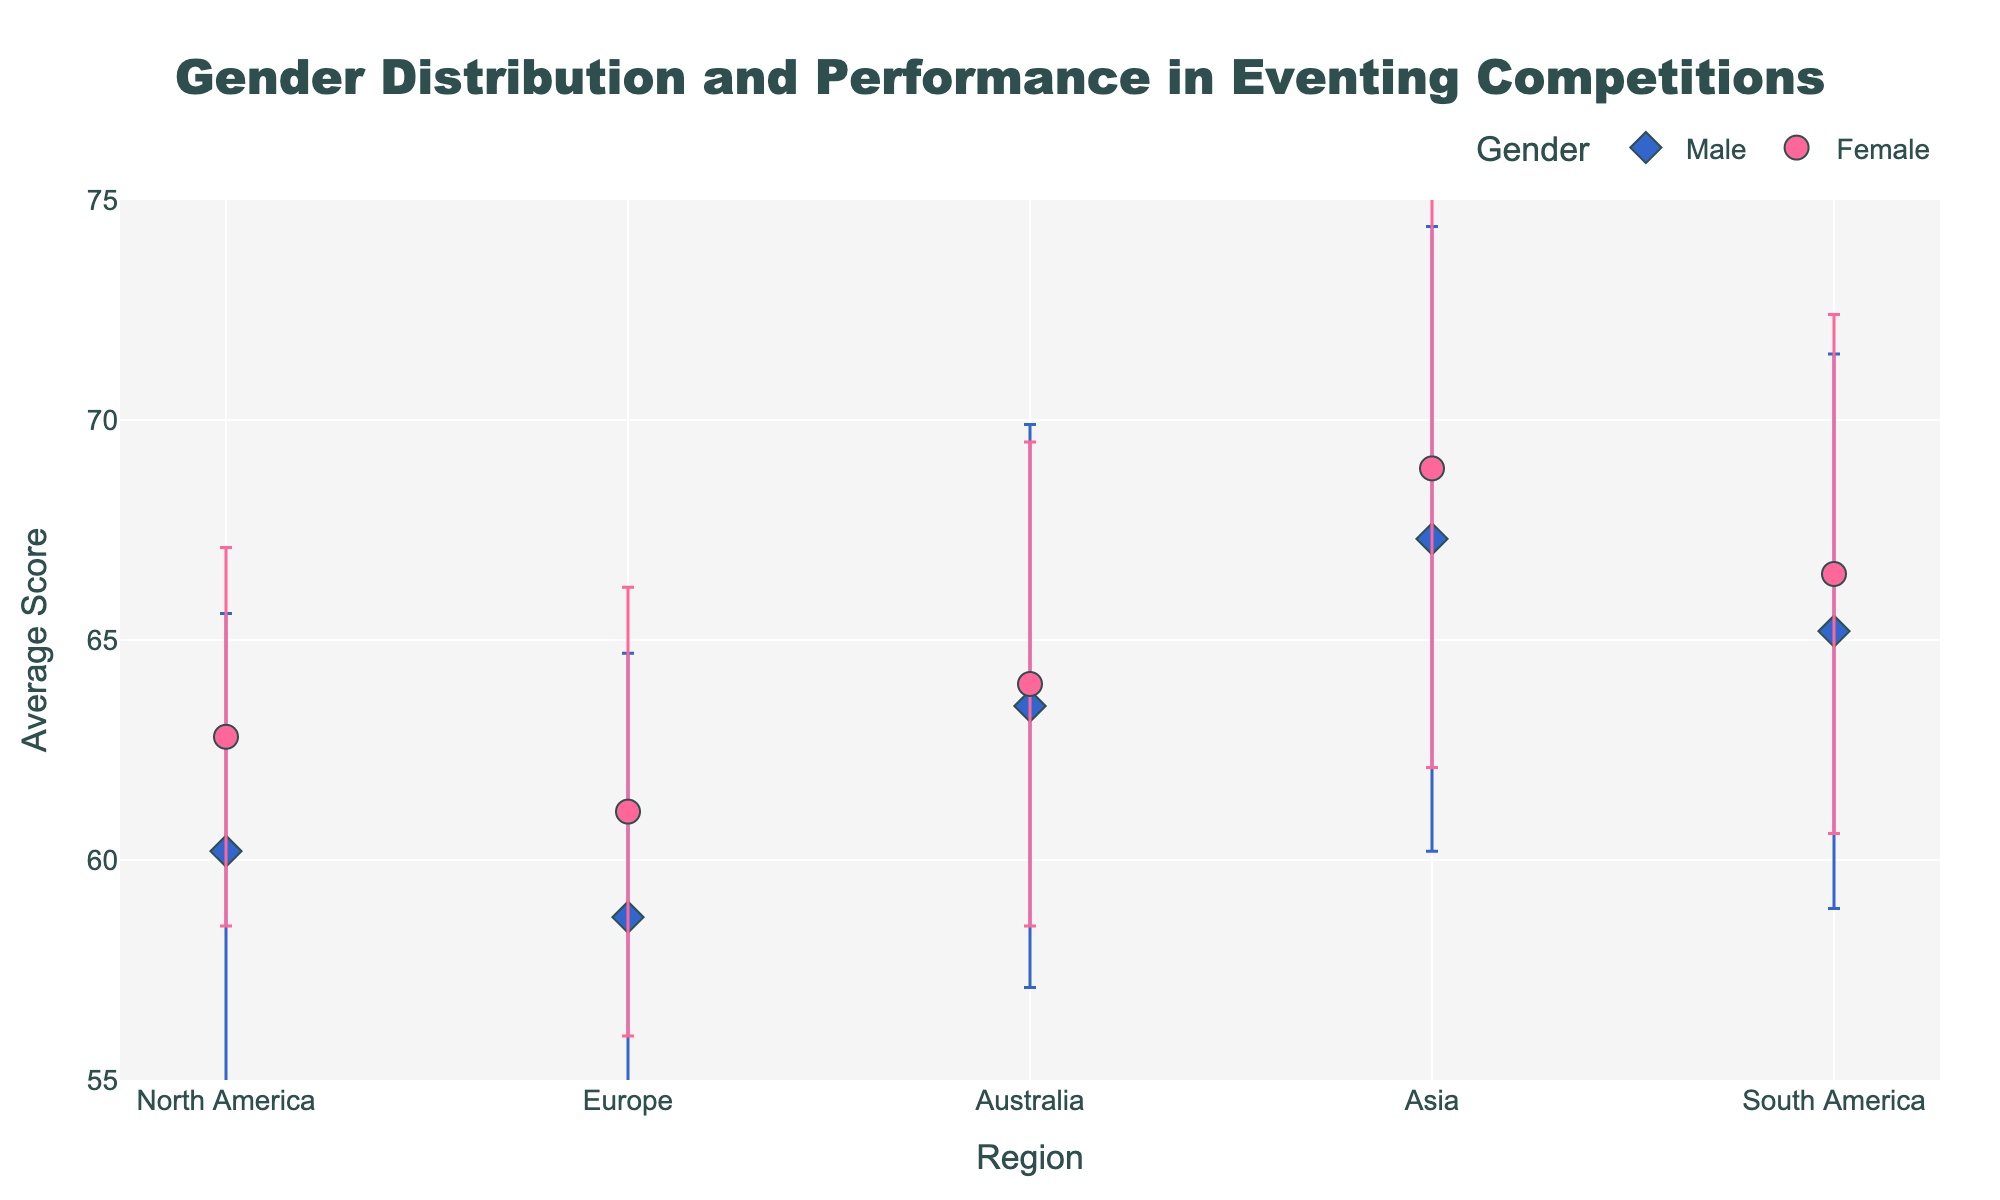What is the title of the plot? The title of the plot is displayed at the top center of the figure.
Answer: Gender Distribution and Performance in Eventing Competitions What is the average score for female competitors in Asia? Locate the dot representing female competitors in Asia on the y-axis and read the corresponding value.
Answer: 68.9 What are the regions compared in the plot? Look at the labels on the x-axis to identify the regions.
Answer: North America, Europe, Australia, Asia, South America Which gender in North America has a higher average score? Compare the two dots representing the male and female scores in North America and see which one is higher on the y-axis.
Answer: Female Which region has the highest average score for male competitors? Find the male score in each region and compare their heights to determine the highest.
Answer: Asia Between male and female competitors in Europe, who has a wider range of performance? Compare the lengths of the error bars for male and female competitors in Europe to see which is longer.
Answer: Male What can be inferred about the performance consistency of competitors in North America? Consistency in performance can be inferred by looking at the standard deviations represented by the error bars. Shorter error bars suggest higher consistency.
Answer: Female competitors in North America have more consistent performance How do the average scores of female competitors in South America compare to those in Europe? Compare the y-axis values of the dots representing female competitors in South America and Europe.
Answer: South America has a higher average score Are there any regions where male competitors have higher average scores than female competitors? Compare the average scores (y-axis values) of male and female competitors for each region.
Answer: No 